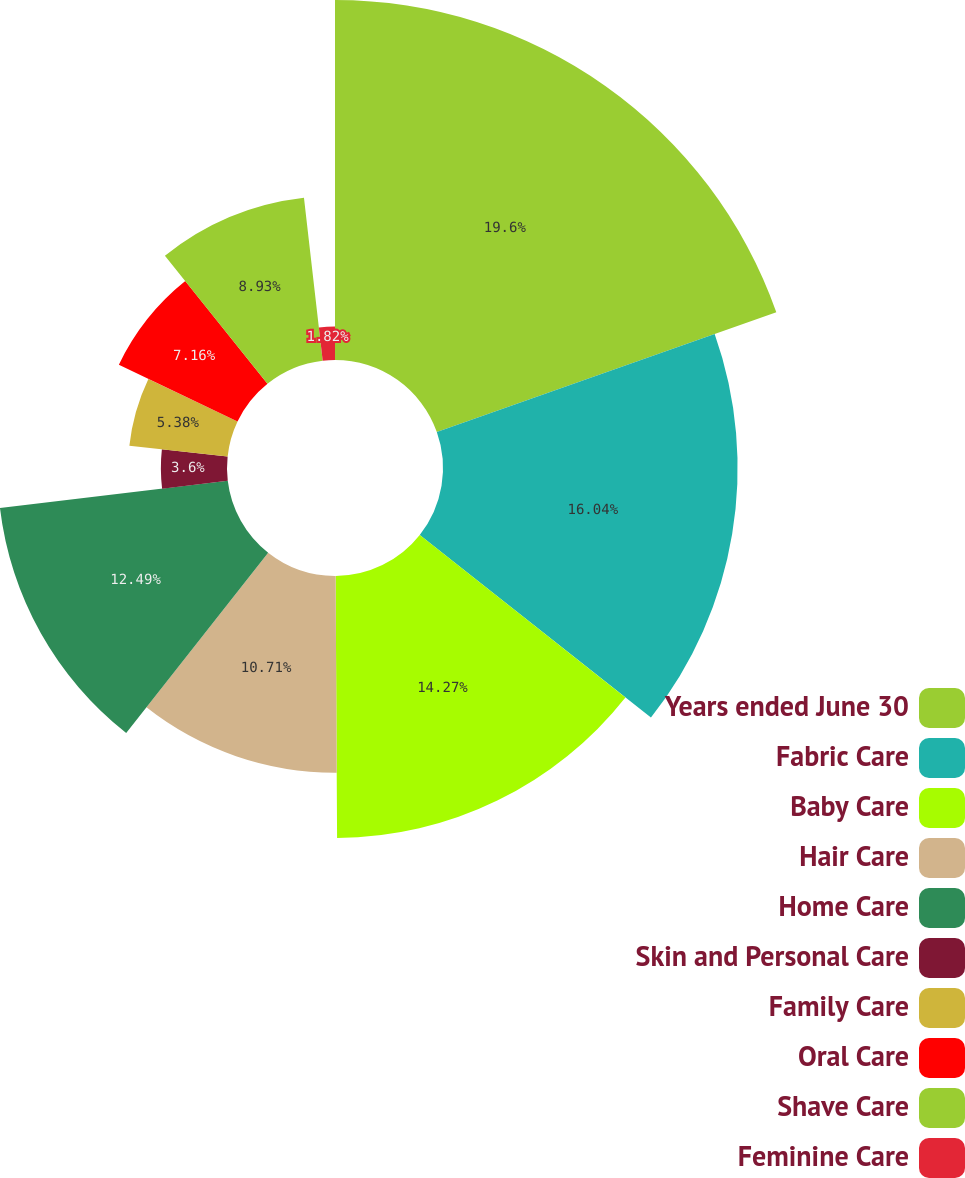Convert chart to OTSL. <chart><loc_0><loc_0><loc_500><loc_500><pie_chart><fcel>Years ended June 30<fcel>Fabric Care<fcel>Baby Care<fcel>Hair Care<fcel>Home Care<fcel>Skin and Personal Care<fcel>Family Care<fcel>Oral Care<fcel>Shave Care<fcel>Feminine Care<nl><fcel>19.6%<fcel>16.04%<fcel>14.27%<fcel>10.71%<fcel>12.49%<fcel>3.6%<fcel>5.38%<fcel>7.16%<fcel>8.93%<fcel>1.82%<nl></chart> 